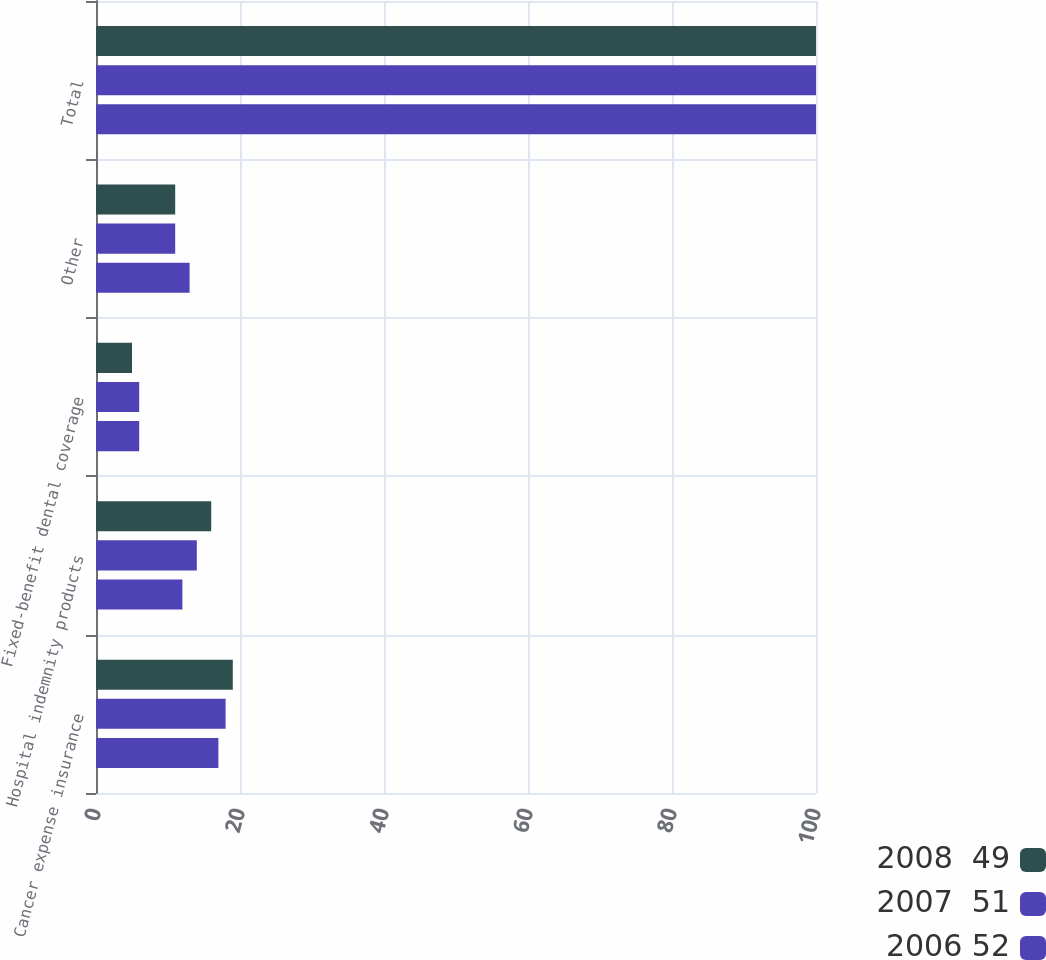Convert chart. <chart><loc_0><loc_0><loc_500><loc_500><stacked_bar_chart><ecel><fcel>Cancer expense insurance<fcel>Hospital indemnity products<fcel>Fixed-benefit dental coverage<fcel>Other<fcel>Total<nl><fcel>2008  49<fcel>19<fcel>16<fcel>5<fcel>11<fcel>100<nl><fcel>2007  51<fcel>18<fcel>14<fcel>6<fcel>11<fcel>100<nl><fcel>2006 52<fcel>17<fcel>12<fcel>6<fcel>13<fcel>100<nl></chart> 